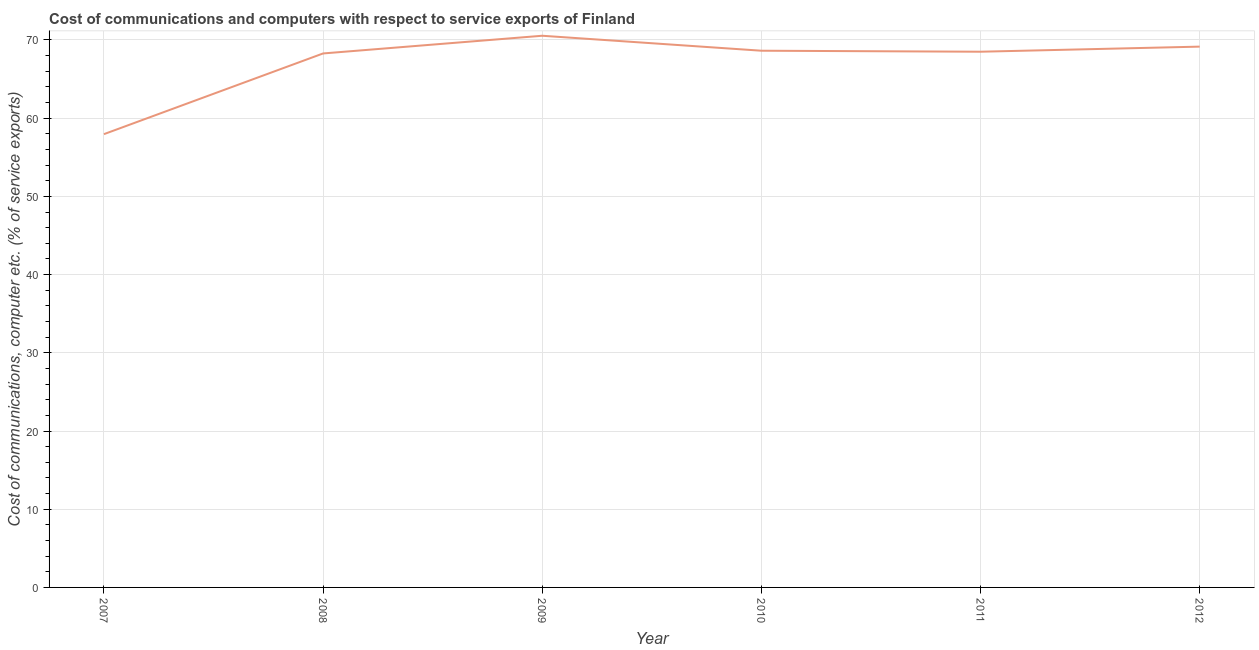What is the cost of communications and computer in 2012?
Ensure brevity in your answer.  69.15. Across all years, what is the maximum cost of communications and computer?
Your answer should be compact. 70.54. Across all years, what is the minimum cost of communications and computer?
Provide a succinct answer. 57.95. In which year was the cost of communications and computer maximum?
Your answer should be very brief. 2009. What is the sum of the cost of communications and computer?
Give a very brief answer. 403.04. What is the difference between the cost of communications and computer in 2008 and 2012?
Ensure brevity in your answer.  -0.87. What is the average cost of communications and computer per year?
Provide a short and direct response. 67.17. What is the median cost of communications and computer?
Your response must be concise. 68.56. What is the ratio of the cost of communications and computer in 2008 to that in 2010?
Keep it short and to the point. 0.99. What is the difference between the highest and the second highest cost of communications and computer?
Make the answer very short. 1.39. What is the difference between the highest and the lowest cost of communications and computer?
Provide a short and direct response. 12.58. In how many years, is the cost of communications and computer greater than the average cost of communications and computer taken over all years?
Your response must be concise. 5. How many years are there in the graph?
Offer a very short reply. 6. What is the title of the graph?
Offer a very short reply. Cost of communications and computers with respect to service exports of Finland. What is the label or title of the Y-axis?
Your response must be concise. Cost of communications, computer etc. (% of service exports). What is the Cost of communications, computer etc. (% of service exports) of 2007?
Offer a very short reply. 57.95. What is the Cost of communications, computer etc. (% of service exports) in 2008?
Make the answer very short. 68.27. What is the Cost of communications, computer etc. (% of service exports) in 2009?
Your response must be concise. 70.54. What is the Cost of communications, computer etc. (% of service exports) of 2010?
Your answer should be compact. 68.62. What is the Cost of communications, computer etc. (% of service exports) in 2011?
Make the answer very short. 68.5. What is the Cost of communications, computer etc. (% of service exports) in 2012?
Your response must be concise. 69.15. What is the difference between the Cost of communications, computer etc. (% of service exports) in 2007 and 2008?
Offer a terse response. -10.32. What is the difference between the Cost of communications, computer etc. (% of service exports) in 2007 and 2009?
Your response must be concise. -12.58. What is the difference between the Cost of communications, computer etc. (% of service exports) in 2007 and 2010?
Your response must be concise. -10.67. What is the difference between the Cost of communications, computer etc. (% of service exports) in 2007 and 2011?
Your answer should be compact. -10.54. What is the difference between the Cost of communications, computer etc. (% of service exports) in 2007 and 2012?
Provide a succinct answer. -11.19. What is the difference between the Cost of communications, computer etc. (% of service exports) in 2008 and 2009?
Your answer should be compact. -2.26. What is the difference between the Cost of communications, computer etc. (% of service exports) in 2008 and 2010?
Keep it short and to the point. -0.35. What is the difference between the Cost of communications, computer etc. (% of service exports) in 2008 and 2011?
Your response must be concise. -0.22. What is the difference between the Cost of communications, computer etc. (% of service exports) in 2008 and 2012?
Give a very brief answer. -0.87. What is the difference between the Cost of communications, computer etc. (% of service exports) in 2009 and 2010?
Offer a very short reply. 1.91. What is the difference between the Cost of communications, computer etc. (% of service exports) in 2009 and 2011?
Your response must be concise. 2.04. What is the difference between the Cost of communications, computer etc. (% of service exports) in 2009 and 2012?
Provide a short and direct response. 1.39. What is the difference between the Cost of communications, computer etc. (% of service exports) in 2010 and 2011?
Keep it short and to the point. 0.13. What is the difference between the Cost of communications, computer etc. (% of service exports) in 2010 and 2012?
Your response must be concise. -0.52. What is the difference between the Cost of communications, computer etc. (% of service exports) in 2011 and 2012?
Your answer should be compact. -0.65. What is the ratio of the Cost of communications, computer etc. (% of service exports) in 2007 to that in 2008?
Provide a succinct answer. 0.85. What is the ratio of the Cost of communications, computer etc. (% of service exports) in 2007 to that in 2009?
Provide a succinct answer. 0.82. What is the ratio of the Cost of communications, computer etc. (% of service exports) in 2007 to that in 2010?
Your response must be concise. 0.84. What is the ratio of the Cost of communications, computer etc. (% of service exports) in 2007 to that in 2011?
Give a very brief answer. 0.85. What is the ratio of the Cost of communications, computer etc. (% of service exports) in 2007 to that in 2012?
Your answer should be very brief. 0.84. What is the ratio of the Cost of communications, computer etc. (% of service exports) in 2008 to that in 2009?
Give a very brief answer. 0.97. What is the ratio of the Cost of communications, computer etc. (% of service exports) in 2008 to that in 2011?
Ensure brevity in your answer.  1. What is the ratio of the Cost of communications, computer etc. (% of service exports) in 2008 to that in 2012?
Give a very brief answer. 0.99. What is the ratio of the Cost of communications, computer etc. (% of service exports) in 2009 to that in 2010?
Keep it short and to the point. 1.03. What is the ratio of the Cost of communications, computer etc. (% of service exports) in 2009 to that in 2011?
Keep it short and to the point. 1.03. What is the ratio of the Cost of communications, computer etc. (% of service exports) in 2010 to that in 2011?
Offer a very short reply. 1. What is the ratio of the Cost of communications, computer etc. (% of service exports) in 2011 to that in 2012?
Your answer should be very brief. 0.99. 